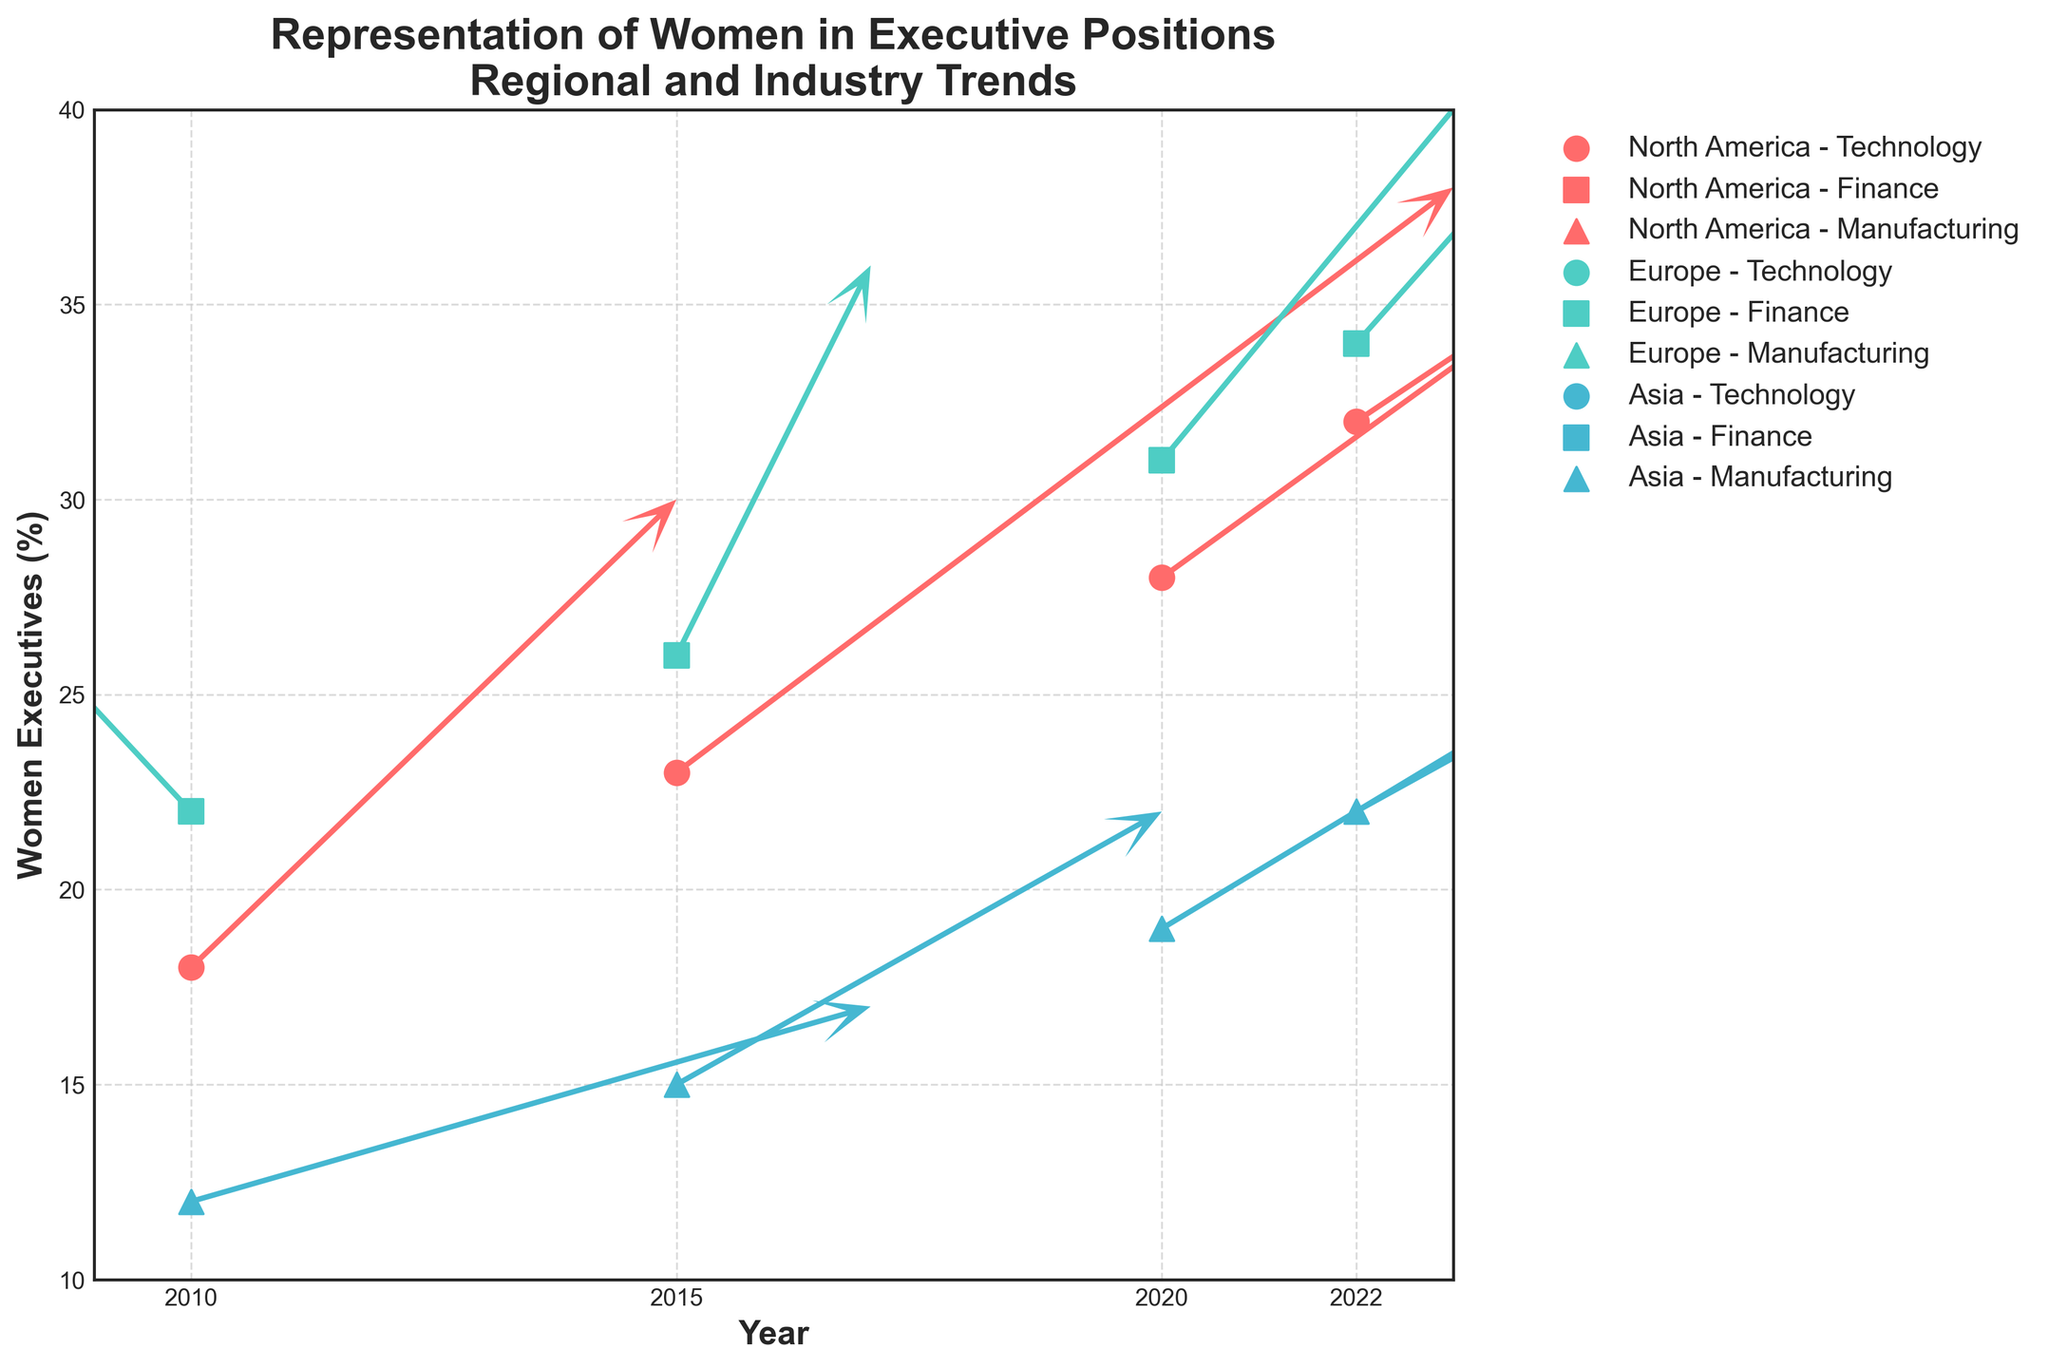What is the title of the figure? The title is usually placed at the top of the figure. The title is "Representation of Women in Executive Positions\nRegional and Industry Trends".
Answer: Representation of Women in Executive Positions\nRegional and Industry Trends Which region has the highest percentage of women executives in 2022? The quiver plot shows data points with different colors for different regions and percentages of women executives for the year 2022. Look for the highest y-value in 2022.
Answer: Europe How did the percentage of women executives in the Finance industry in Europe change from 2010 to 2022? The quiver plot uses directional arrows to show changes over time. Observe the y-values for Europe Finance from 2010 to 2022. The values are 22 in 2010 and 34 in 2022, so the change is 34 - 22 = 12%.
Answer: Increased by 12% Compare the change rates in the Technology industry in North America between 2015 and 2020. Look for the directional arrows corresponding to North America Technology for the years 2015 and 2020. Compare the length and direction of the quivers. In 2015, the change rate is (0.8, 1.5) and in 2020 it's (1.0, 1.8). The values differ by (1.0 - 0.8, 1.8 - 1.5) = (0.2, 0.3).
Answer: Increased by (0.2, 0.3) Which industry in Asia shows the highest increase in women executive percentages from 2010 to 2022? Find the y-values for Asia across industries from 2010 to 2022. Compare the differences. Manufacturing shows an increase from 12 to 22, Technology and Finance data is not provided.
Answer: Manufacturing Did any region in the Technology industry maintain a consistent increase in the percentage of women executives from 2010 to 2022? Check the y-values for the Technology industry across regions over the years. North America has a consistent increase from 18% in 2010 to 32% in 2022.
Answer: Yes, North America Which year had the largest increase in the percentage of women executives in the Finance industry in Europe? Compare the lengths of quivers for Finance in Europe for each time window. The largest increase quiver is from 2020 to 2022, corresponding to a u and v.
Answer: 2020 to 2022 In 2020, which industry in Asia overtook the Technology industry in North America in terms of the percentage of women executives? Compare the 2020 y-values for Asia's industries against the Technology industry in North America. No industry in Asia overtook North America's Technology.
Answer: None How does the percentage of women executives in Manufacturing in Asia change from 2015 to 2022? Look at the data points for Asia Manufacturing from 2015 and 2022. The quiver shows changes between these years. The percentage increases from 15% in 2015 to 22% in 2022.
Answer: Increased by 7% 